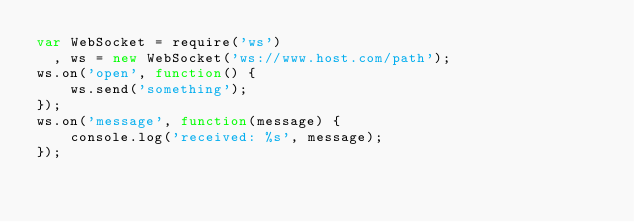Convert code to text. <code><loc_0><loc_0><loc_500><loc_500><_JavaScript_>var WebSocket = require('ws')
  , ws = new WebSocket('ws://www.host.com/path');
ws.on('open', function() {
    ws.send('something');
});
ws.on('message', function(message) {
    console.log('received: %s', message);
});</code> 